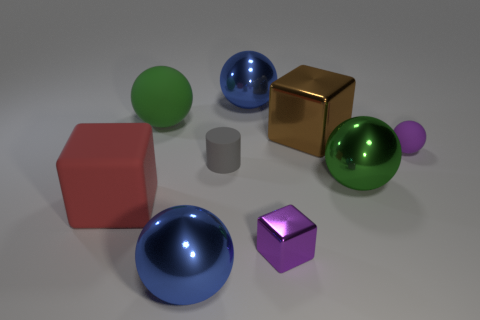What possible functions could these objects have if they were larger and part of a playground? If scaled up for a playground, the sphere could function as a ball for children to roll, the cube might become a climbing structure, the cylinder could turn into a tunnel to crawl through, and the smaller shapes might serve as seats or decorative elements. Each could offer a distinct type of interactive play, blending physical activity and sensory exploration. 